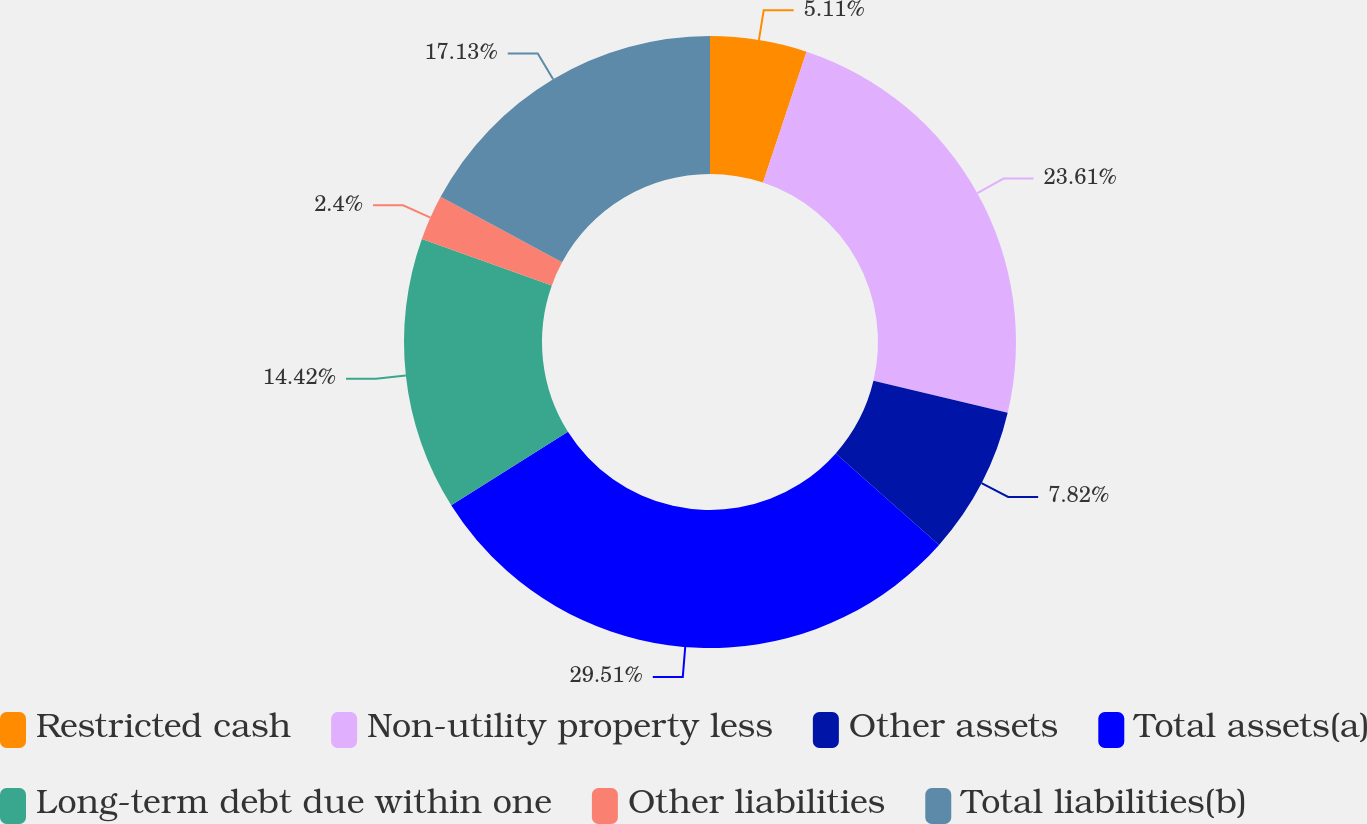Convert chart to OTSL. <chart><loc_0><loc_0><loc_500><loc_500><pie_chart><fcel>Restricted cash<fcel>Non-utility property less<fcel>Other assets<fcel>Total assets(a)<fcel>Long-term debt due within one<fcel>Other liabilities<fcel>Total liabilities(b)<nl><fcel>5.11%<fcel>23.6%<fcel>7.82%<fcel>29.5%<fcel>14.42%<fcel>2.4%<fcel>17.13%<nl></chart> 